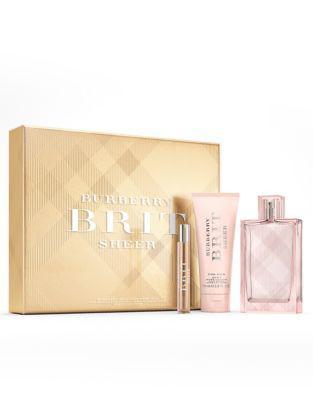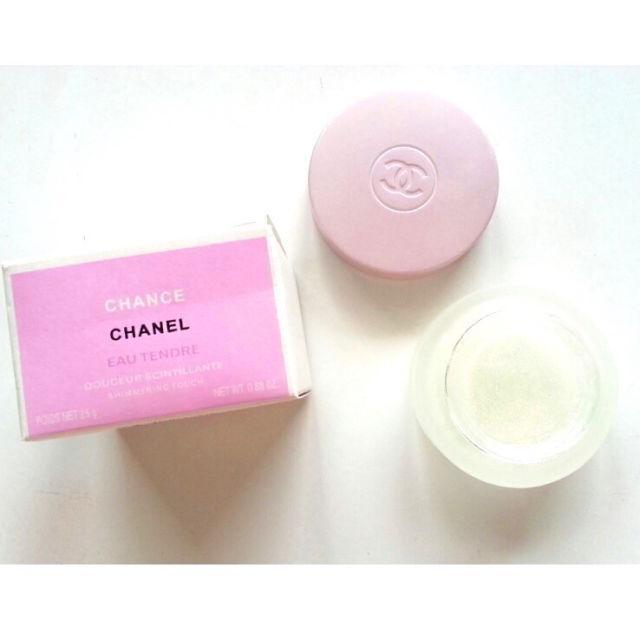The first image is the image on the left, the second image is the image on the right. Examine the images to the left and right. Is the description "In at least one image there are at least two bottle of perfume and at least one box" accurate? Answer yes or no. No. The first image is the image on the left, the second image is the image on the right. Evaluate the accuracy of this statement regarding the images: "There is at least one bottle of perfume being displayed in the center of both images.". Is it true? Answer yes or no. No. 